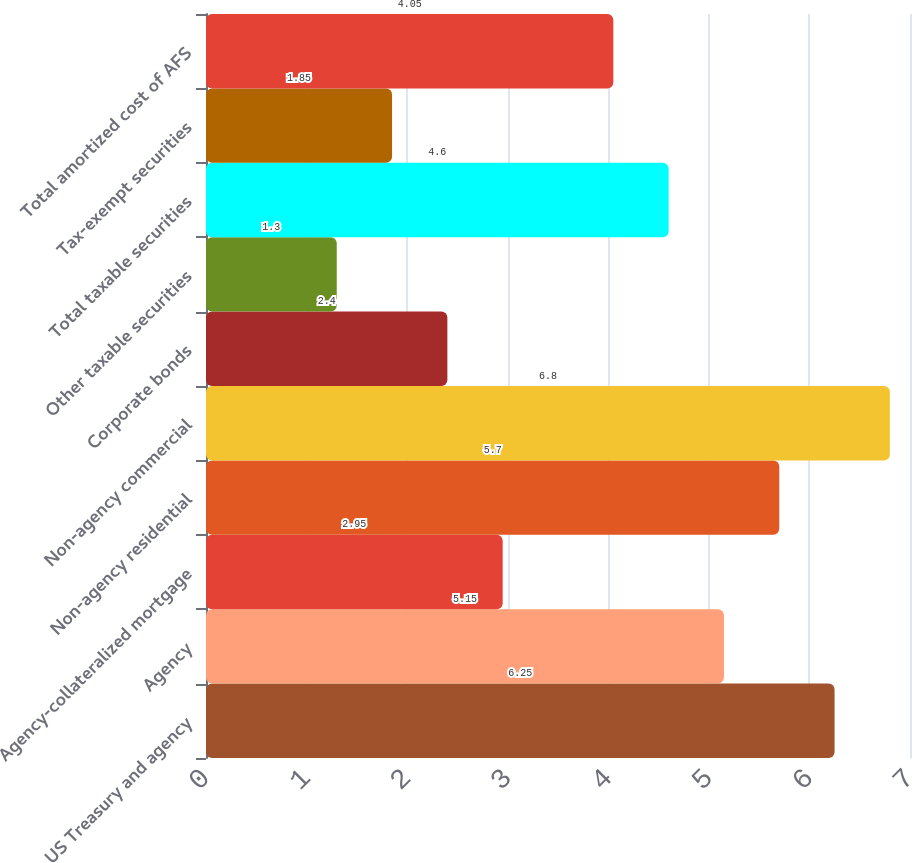Convert chart to OTSL. <chart><loc_0><loc_0><loc_500><loc_500><bar_chart><fcel>US Treasury and agency<fcel>Agency<fcel>Agency-collateralized mortgage<fcel>Non-agency residential<fcel>Non-agency commercial<fcel>Corporate bonds<fcel>Other taxable securities<fcel>Total taxable securities<fcel>Tax-exempt securities<fcel>Total amortized cost of AFS<nl><fcel>6.25<fcel>5.15<fcel>2.95<fcel>5.7<fcel>6.8<fcel>2.4<fcel>1.3<fcel>4.6<fcel>1.85<fcel>4.05<nl></chart> 